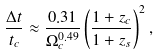<formula> <loc_0><loc_0><loc_500><loc_500>\frac { \Delta t } { t _ { c } } \approx \frac { 0 . 3 1 } { \Omega _ { c } ^ { 0 . 4 9 } } \left ( \frac { 1 + z _ { c } } { 1 + z _ { s } } \right ) ^ { 2 } ,</formula> 